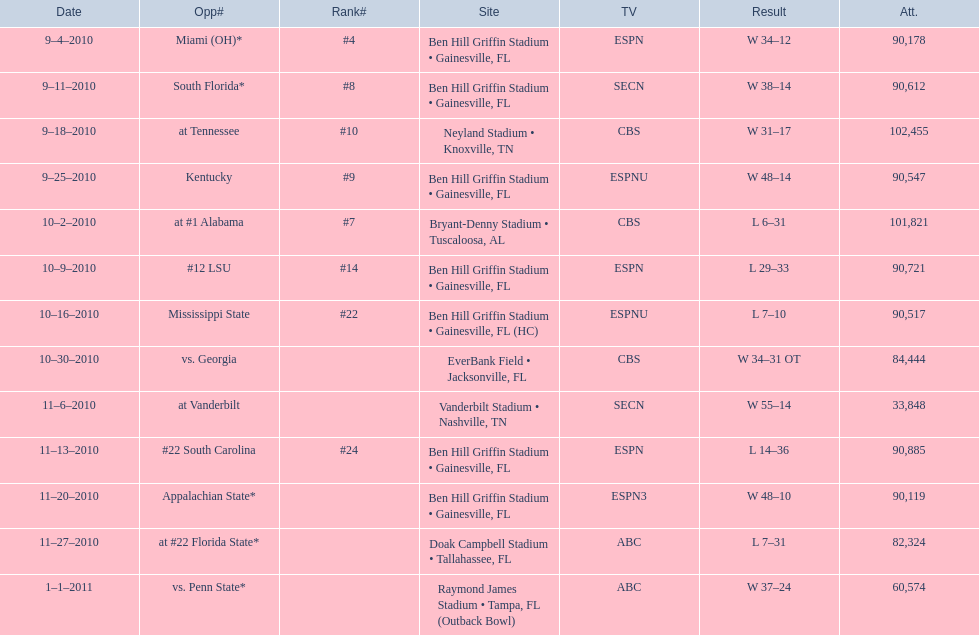How many games did the university of florida win by at least 10 points? 7. 